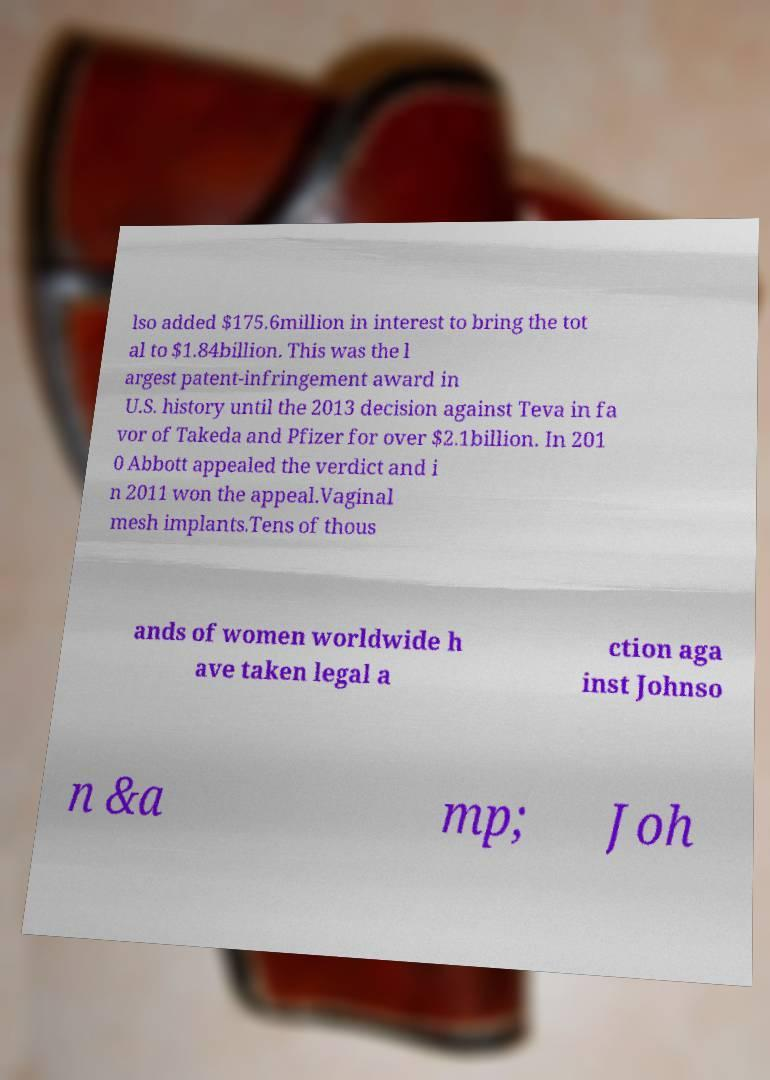There's text embedded in this image that I need extracted. Can you transcribe it verbatim? lso added $175.6million in interest to bring the tot al to $1.84billion. This was the l argest patent-infringement award in U.S. history until the 2013 decision against Teva in fa vor of Takeda and Pfizer for over $2.1billion. In 201 0 Abbott appealed the verdict and i n 2011 won the appeal.Vaginal mesh implants.Tens of thous ands of women worldwide h ave taken legal a ction aga inst Johnso n &a mp; Joh 